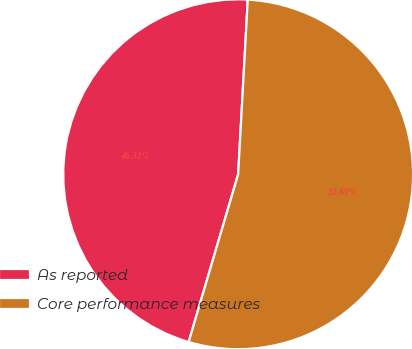Convert chart. <chart><loc_0><loc_0><loc_500><loc_500><pie_chart><fcel>As reported<fcel>Core performance measures<nl><fcel>46.31%<fcel>53.69%<nl></chart> 